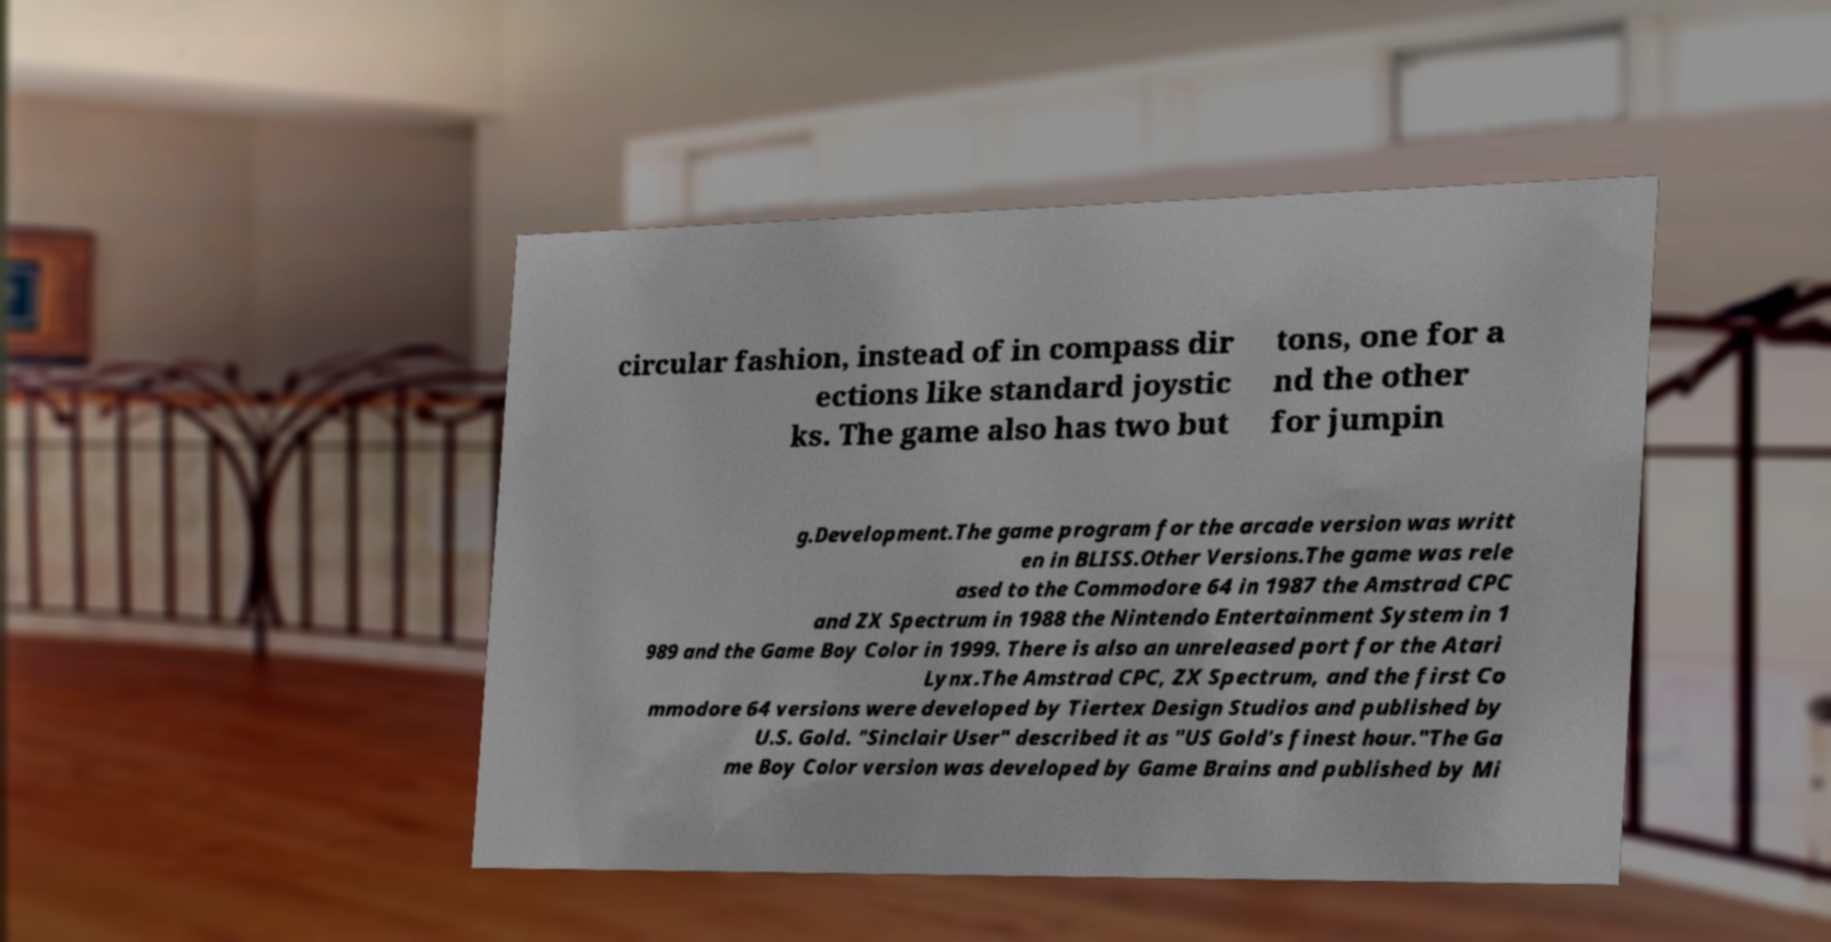What messages or text are displayed in this image? I need them in a readable, typed format. circular fashion, instead of in compass dir ections like standard joystic ks. The game also has two but tons, one for a nd the other for jumpin g.Development.The game program for the arcade version was writt en in BLISS.Other Versions.The game was rele ased to the Commodore 64 in 1987 the Amstrad CPC and ZX Spectrum in 1988 the Nintendo Entertainment System in 1 989 and the Game Boy Color in 1999. There is also an unreleased port for the Atari Lynx.The Amstrad CPC, ZX Spectrum, and the first Co mmodore 64 versions were developed by Tiertex Design Studios and published by U.S. Gold. "Sinclair User" described it as "US Gold's finest hour."The Ga me Boy Color version was developed by Game Brains and published by Mi 